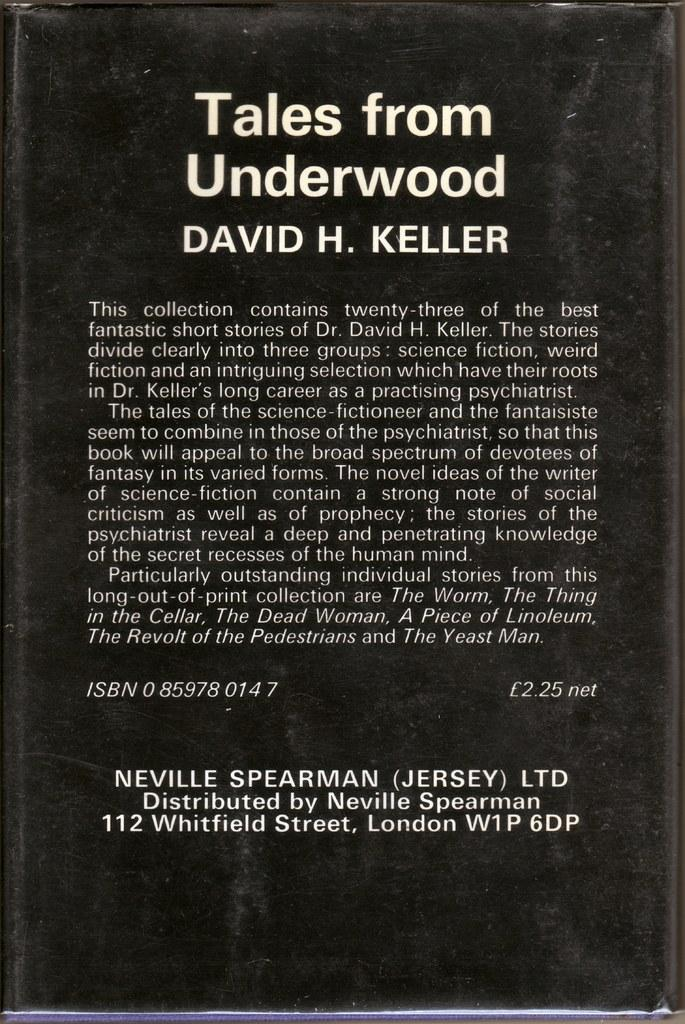Provide a one-sentence caption for the provided image. THE BACK OF A HARCOVERED BOOK BY DAVID KELLER CALLED TALES FROM UNDERWOOD. 